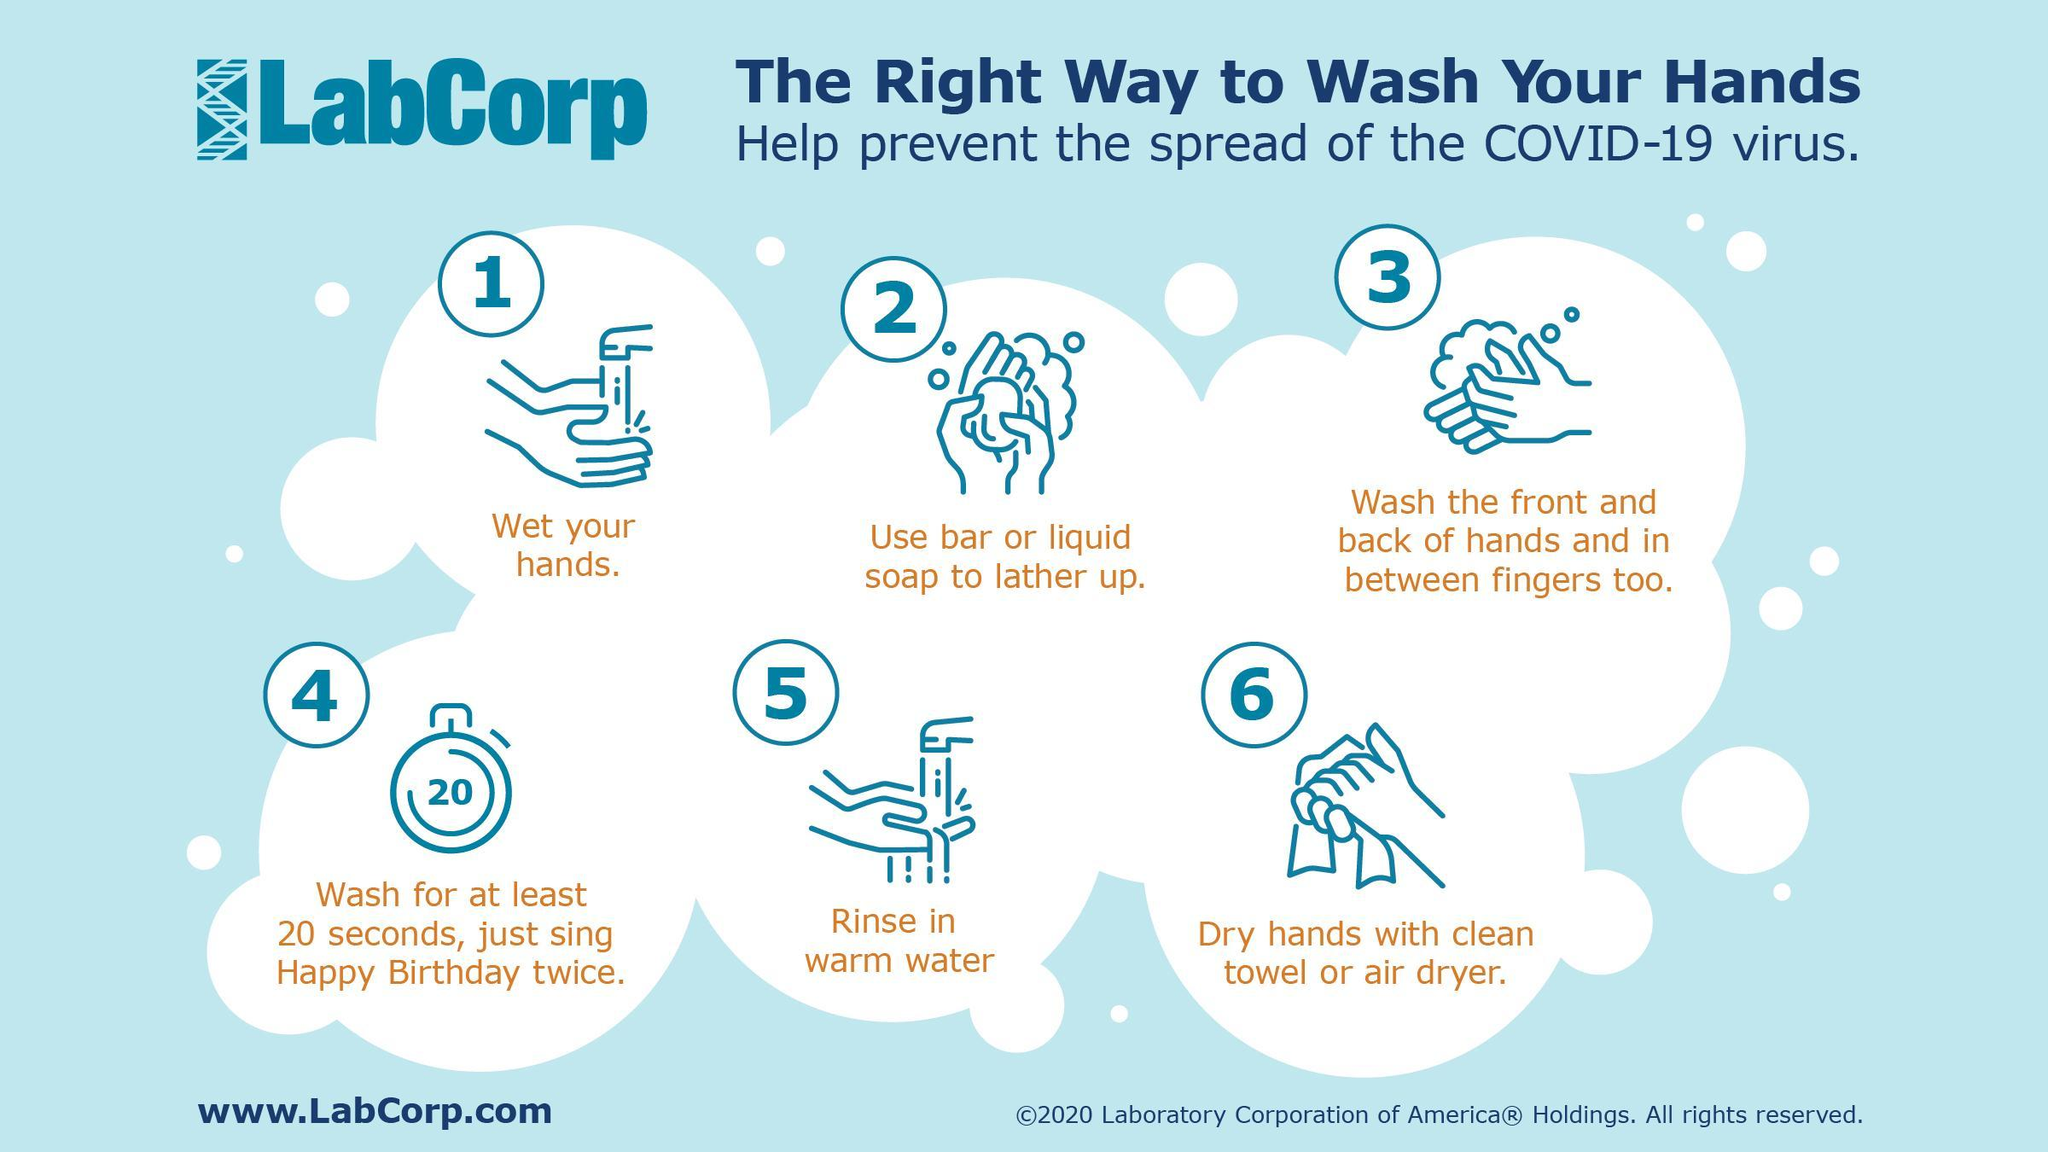In how many steps, hand washing with water is shown?
Answer the question with a short phrase. 2 In which step, dry hands with clean towel or air dryer is shown? 6 How many seconds the hands should be washed inorder to prevent the spread of the Covid-19 virus? 20 seconds 